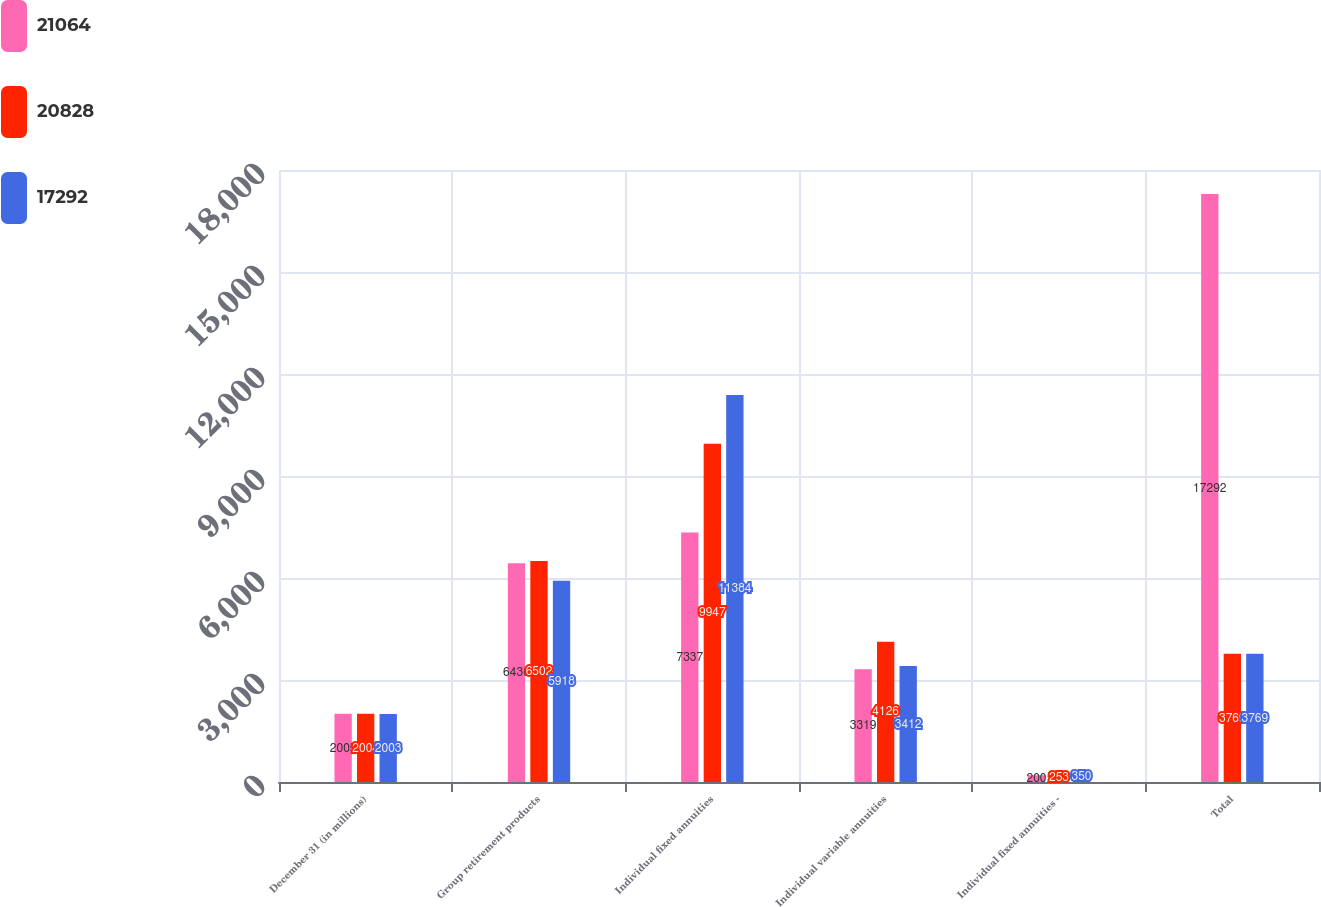Convert chart to OTSL. <chart><loc_0><loc_0><loc_500><loc_500><stacked_bar_chart><ecel><fcel>December 31 (in millions)<fcel>Group retirement products<fcel>Individual fixed annuities<fcel>Individual variable annuities<fcel>Individual fixed annuities -<fcel>Total<nl><fcel>21064<fcel>2005<fcel>6436<fcel>7337<fcel>3319<fcel>200<fcel>17292<nl><fcel>20828<fcel>2004<fcel>6502<fcel>9947<fcel>4126<fcel>253<fcel>3769<nl><fcel>17292<fcel>2003<fcel>5918<fcel>11384<fcel>3412<fcel>350<fcel>3769<nl></chart> 